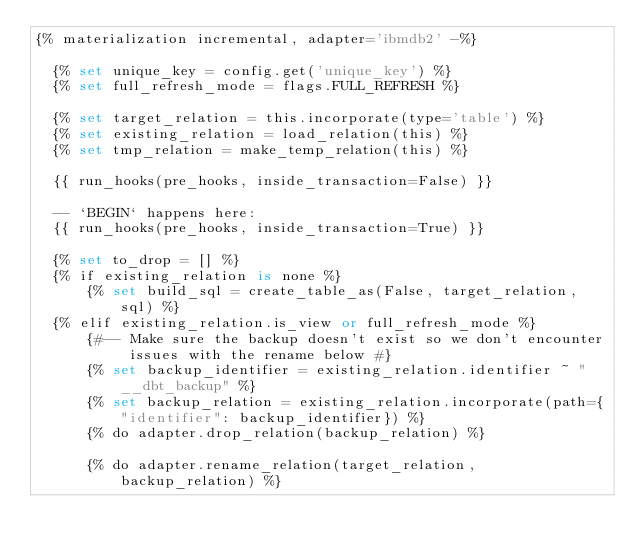Convert code to text. <code><loc_0><loc_0><loc_500><loc_500><_SQL_>{% materialization incremental, adapter='ibmdb2' -%}

  {% set unique_key = config.get('unique_key') %}
  {% set full_refresh_mode = flags.FULL_REFRESH %}

  {% set target_relation = this.incorporate(type='table') %}
  {% set existing_relation = load_relation(this) %}
  {% set tmp_relation = make_temp_relation(this) %}

  {{ run_hooks(pre_hooks, inside_transaction=False) }}

  -- `BEGIN` happens here:
  {{ run_hooks(pre_hooks, inside_transaction=True) }}

  {% set to_drop = [] %}
  {% if existing_relation is none %}
      {% set build_sql = create_table_as(False, target_relation, sql) %}
  {% elif existing_relation.is_view or full_refresh_mode %}
      {#-- Make sure the backup doesn't exist so we don't encounter issues with the rename below #}
      {% set backup_identifier = existing_relation.identifier ~ "__dbt_backup" %}
      {% set backup_relation = existing_relation.incorporate(path={"identifier": backup_identifier}) %}
      {% do adapter.drop_relation(backup_relation) %}

      {% do adapter.rename_relation(target_relation, backup_relation) %}</code> 